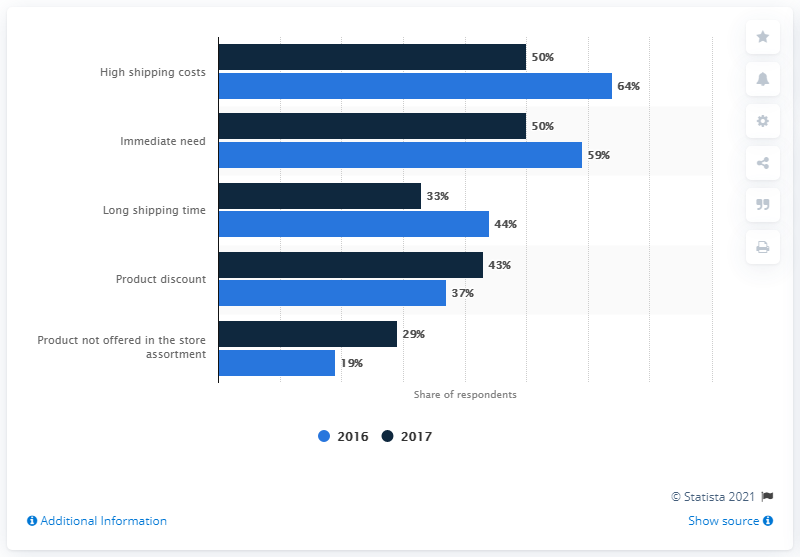Identify some key points in this picture. The average of the largest and smallest bars is 41.5. The smallest bar in the chart represents 19% of the total value. 